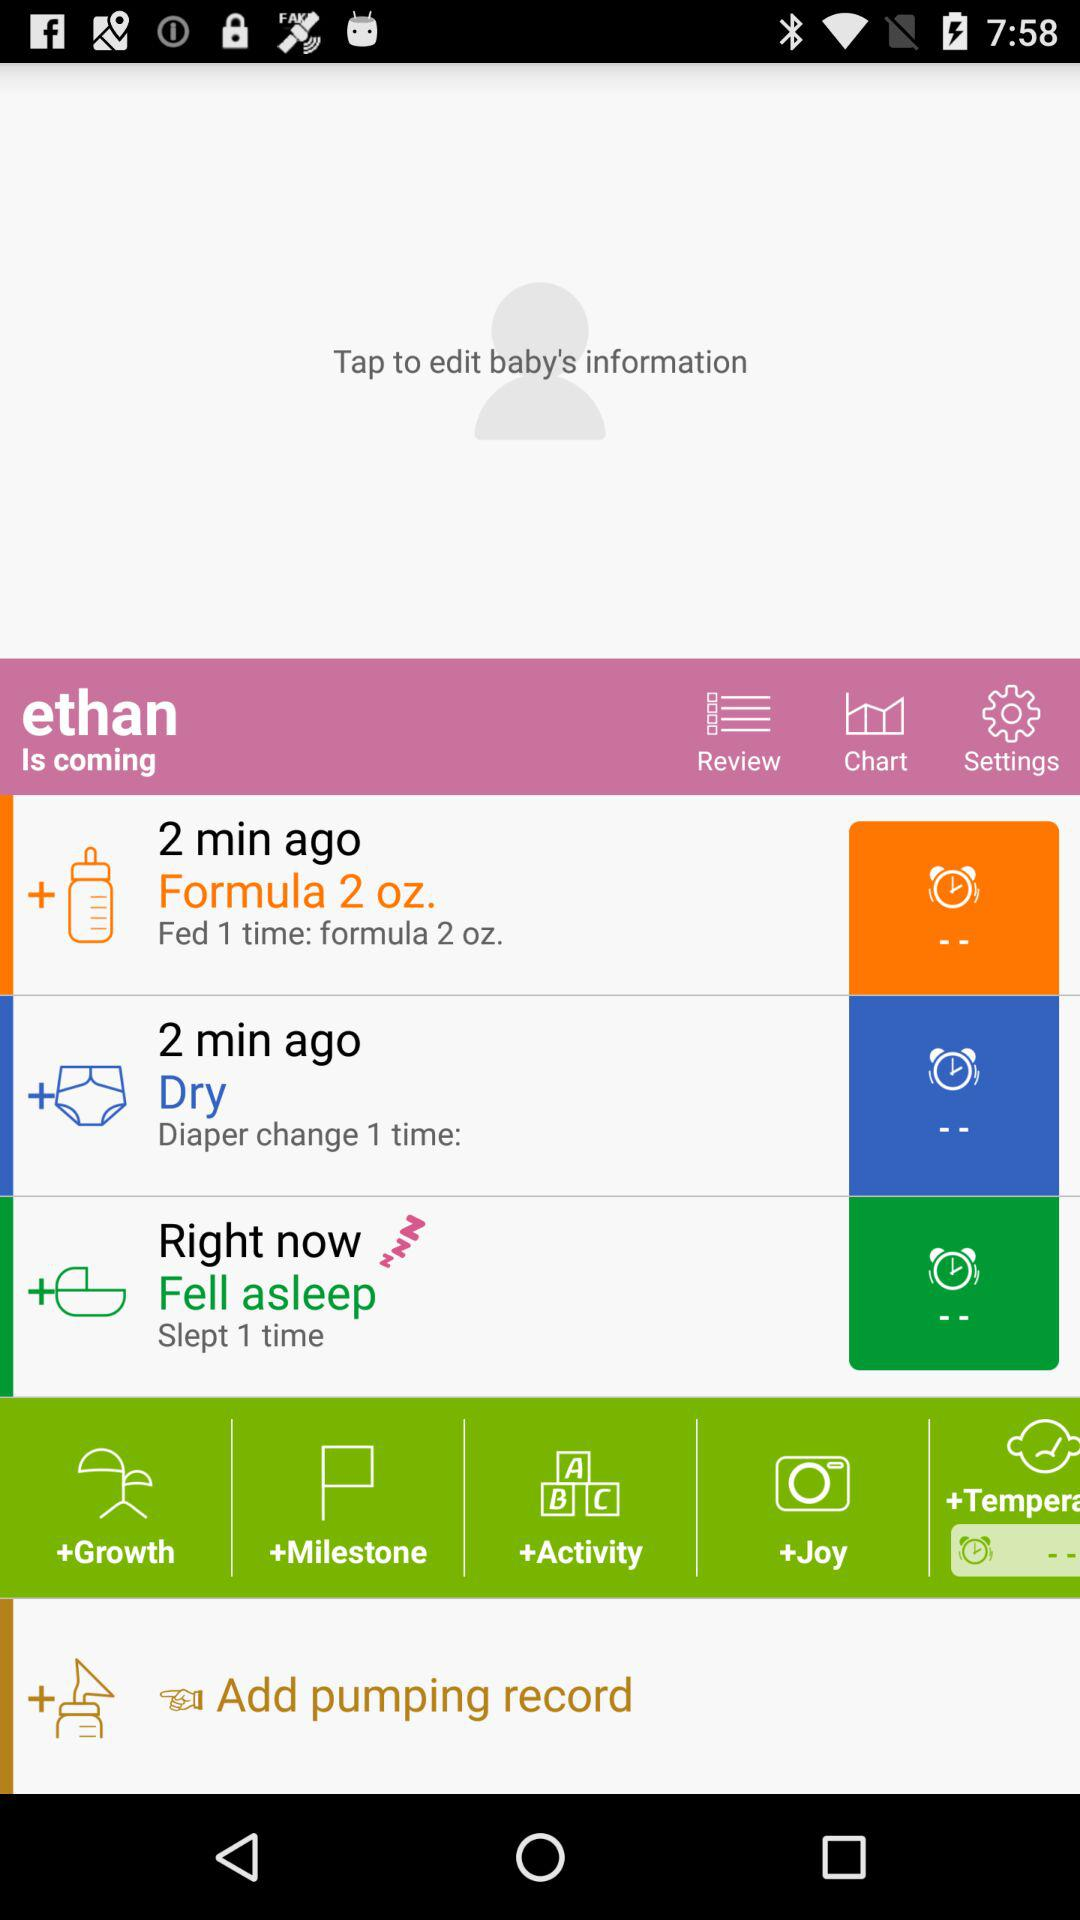What is the quantity fed at one time? The quantity fed at one time is 2 oz. 